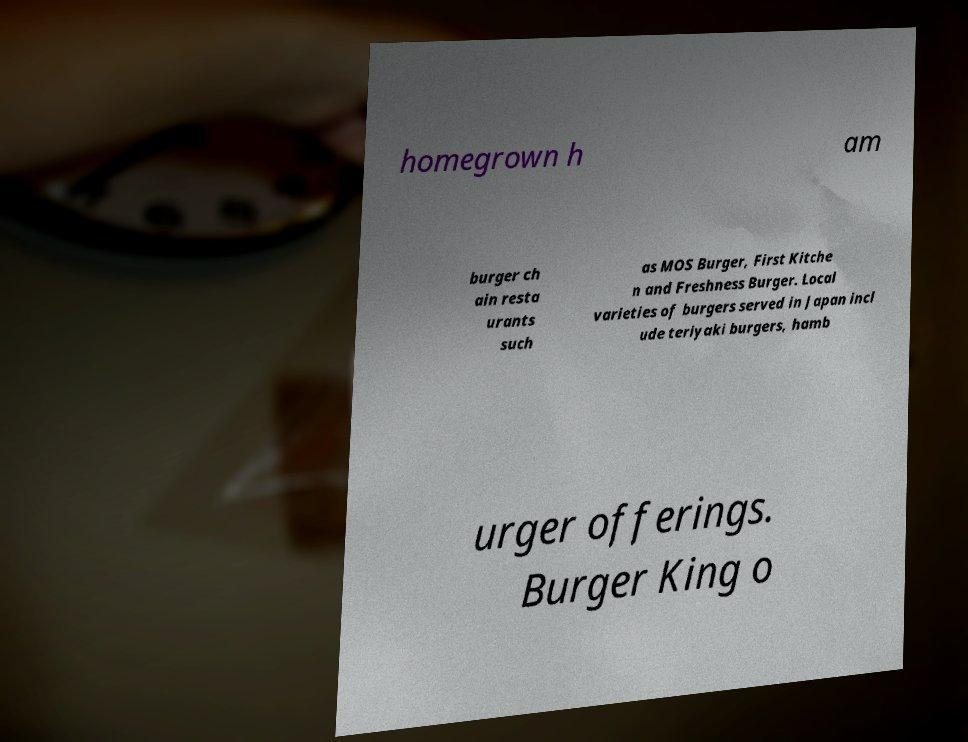For documentation purposes, I need the text within this image transcribed. Could you provide that? homegrown h am burger ch ain resta urants such as MOS Burger, First Kitche n and Freshness Burger. Local varieties of burgers served in Japan incl ude teriyaki burgers, hamb urger offerings. Burger King o 